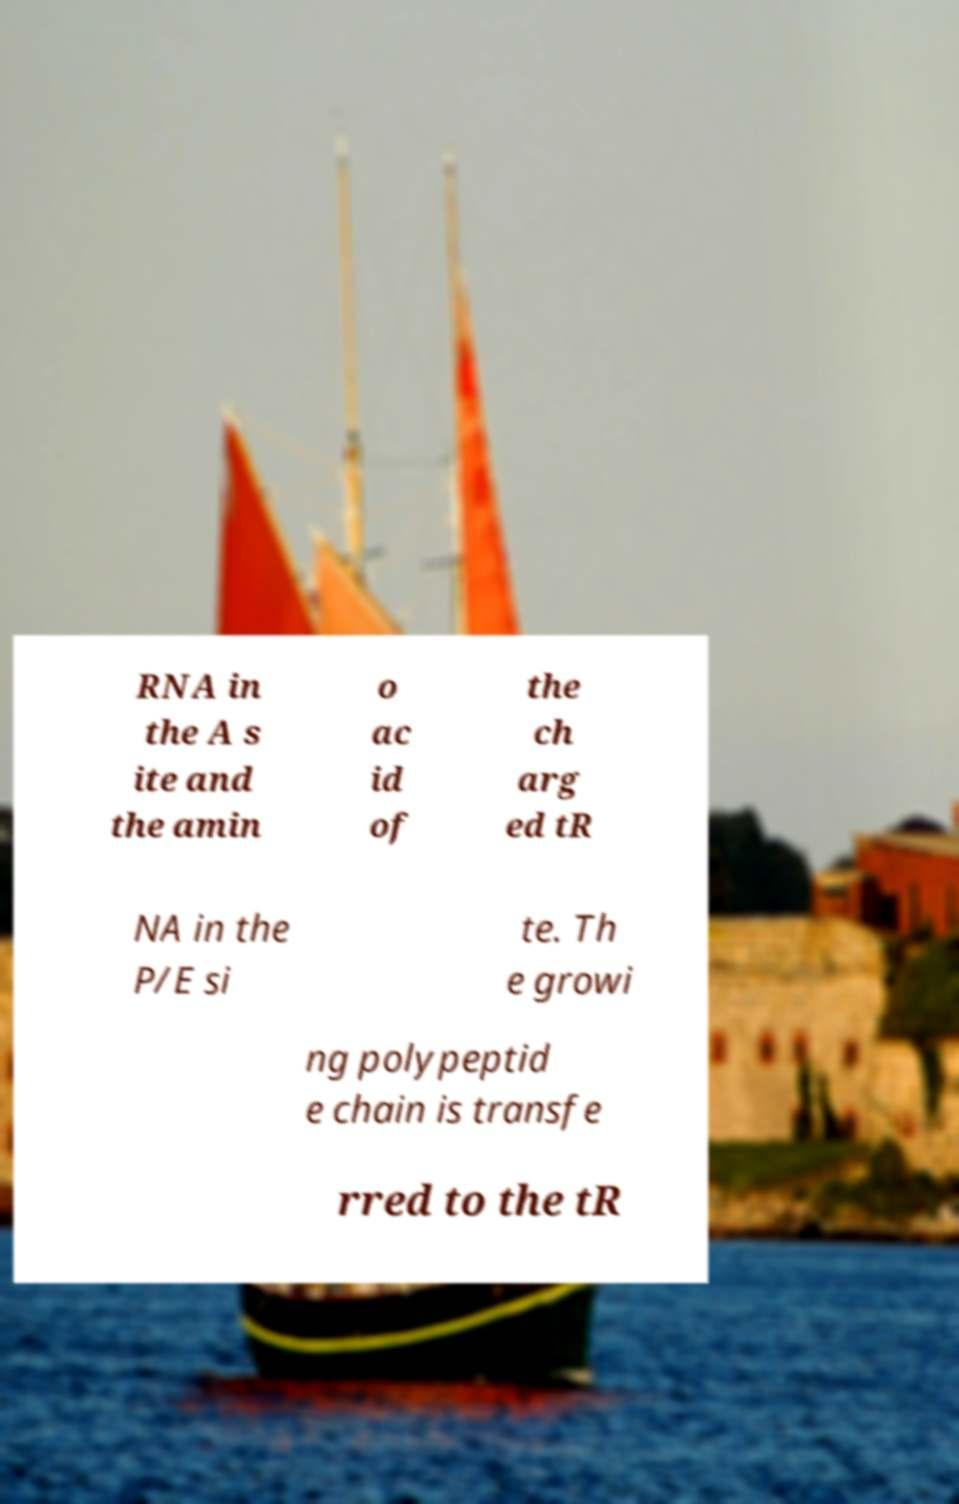Could you extract and type out the text from this image? RNA in the A s ite and the amin o ac id of the ch arg ed tR NA in the P/E si te. Th e growi ng polypeptid e chain is transfe rred to the tR 